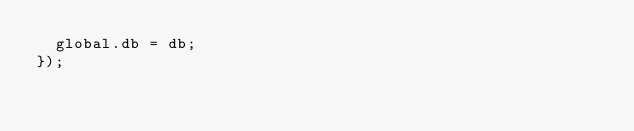Convert code to text. <code><loc_0><loc_0><loc_500><loc_500><_JavaScript_>  global.db = db;
});</code> 